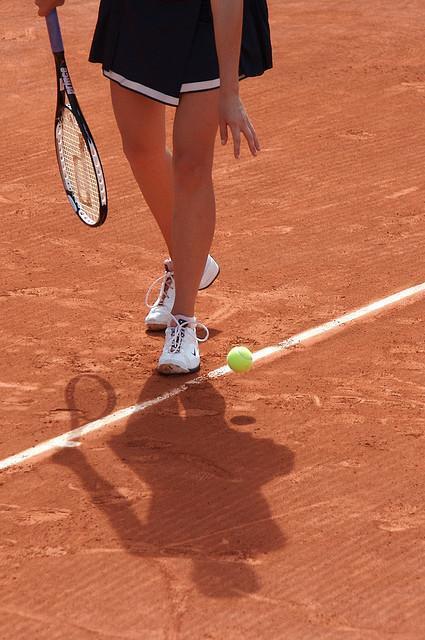How many shadows are present?
Give a very brief answer. 1. 